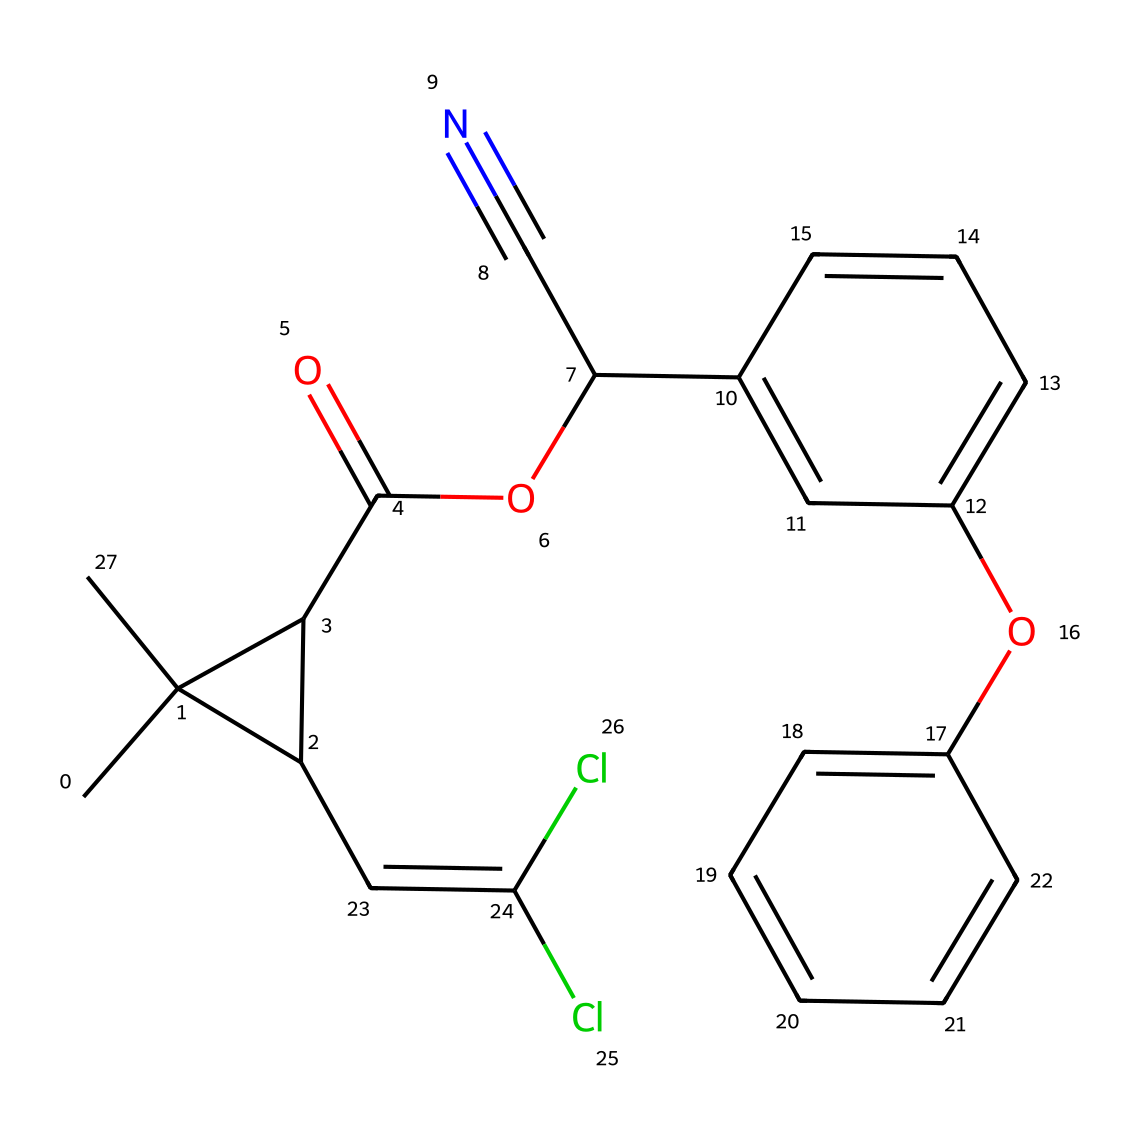What is the molecular formula of deltamethrin? To determine the molecular formula, we analyze the SMILES representation for the various atoms present. Counting the number of carbon (C), hydrogen (H), oxygen (O), and chlorine (Cl) atoms gives us the formula: C22H19Cl2N2O3.
Answer: C22H19Cl2N2O3 How many rings are present in the structure of deltamethrin? By examining the SMILES notation, we identify the presence of cyclic structures denoted by 'C' linked in a ring. Upon inspection, two distinct rings can be observed in the chemical structure.
Answer: 2 What type of pesticide is deltamethrin classified as? Deltamethrin is classified as a pyrethroid, which is a type of insecticide derived from pyrethrins, typically used for controlling pests in various environments including indoor settings.
Answer: pyrethroid How many double bonds are present in the deltamethrin structure? The identification of double bonds within the provided SMILES involves looking for the '=' symbols. In this case, the chemical has three double bonds, which can be visually confirmed in the structure.
Answer: 3 Which part of the structure contributes to its insecticidal properties? Deltamethrin’s insecticidal properties are strongly associated with the specific arrangement of its aromatic rings and the cyano group (C#N), which enhance its toxicity to insects.
Answer: aromatic rings What is the significance of the cyano group in deltamethrin? The cyano group (C#N) contributes to the chemical's effectiveness as a pest control agent by enhancing its toxicity and disrupting the nervous system of the target pests.
Answer: enhances toxicity 